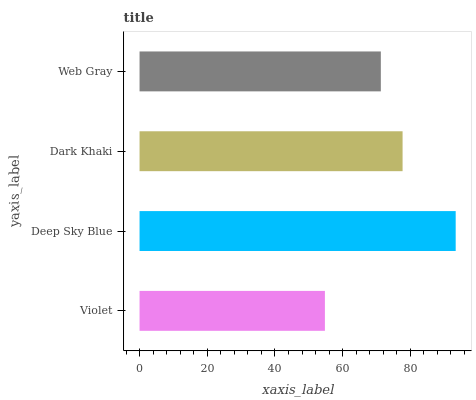Is Violet the minimum?
Answer yes or no. Yes. Is Deep Sky Blue the maximum?
Answer yes or no. Yes. Is Dark Khaki the minimum?
Answer yes or no. No. Is Dark Khaki the maximum?
Answer yes or no. No. Is Deep Sky Blue greater than Dark Khaki?
Answer yes or no. Yes. Is Dark Khaki less than Deep Sky Blue?
Answer yes or no. Yes. Is Dark Khaki greater than Deep Sky Blue?
Answer yes or no. No. Is Deep Sky Blue less than Dark Khaki?
Answer yes or no. No. Is Dark Khaki the high median?
Answer yes or no. Yes. Is Web Gray the low median?
Answer yes or no. Yes. Is Violet the high median?
Answer yes or no. No. Is Deep Sky Blue the low median?
Answer yes or no. No. 